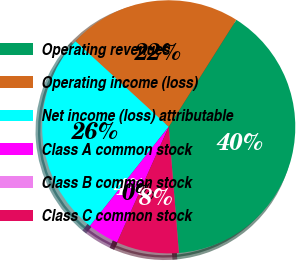Convert chart to OTSL. <chart><loc_0><loc_0><loc_500><loc_500><pie_chart><fcel>Operating revenues<fcel>Operating income (loss)<fcel>Net income (loss) attributable<fcel>Class A common stock<fcel>Class B common stock<fcel>Class C common stock<nl><fcel>39.75%<fcel>22.15%<fcel>26.13%<fcel>3.99%<fcel>0.02%<fcel>7.96%<nl></chart> 